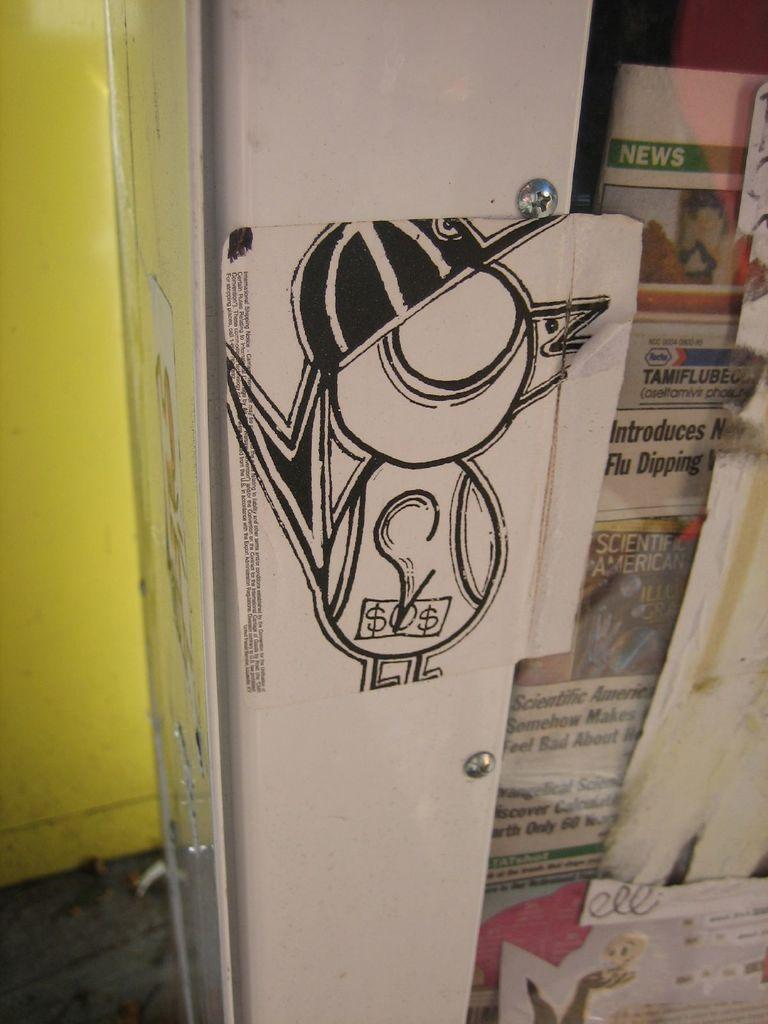What is the main object in the image? There is a white color board in the image. What is placed on or near the color board? There are newspaper pages in the image. Can you describe any text or writing visible in the image? There is writing visible in the background of the image. What type of hardware can be seen in the image? There are screws in the image. What type of animal is sitting on the color board in the image? There is no animal present on the color board in the image. What dish is being served for dinner in the image? There is no dinner or food present in the image. 